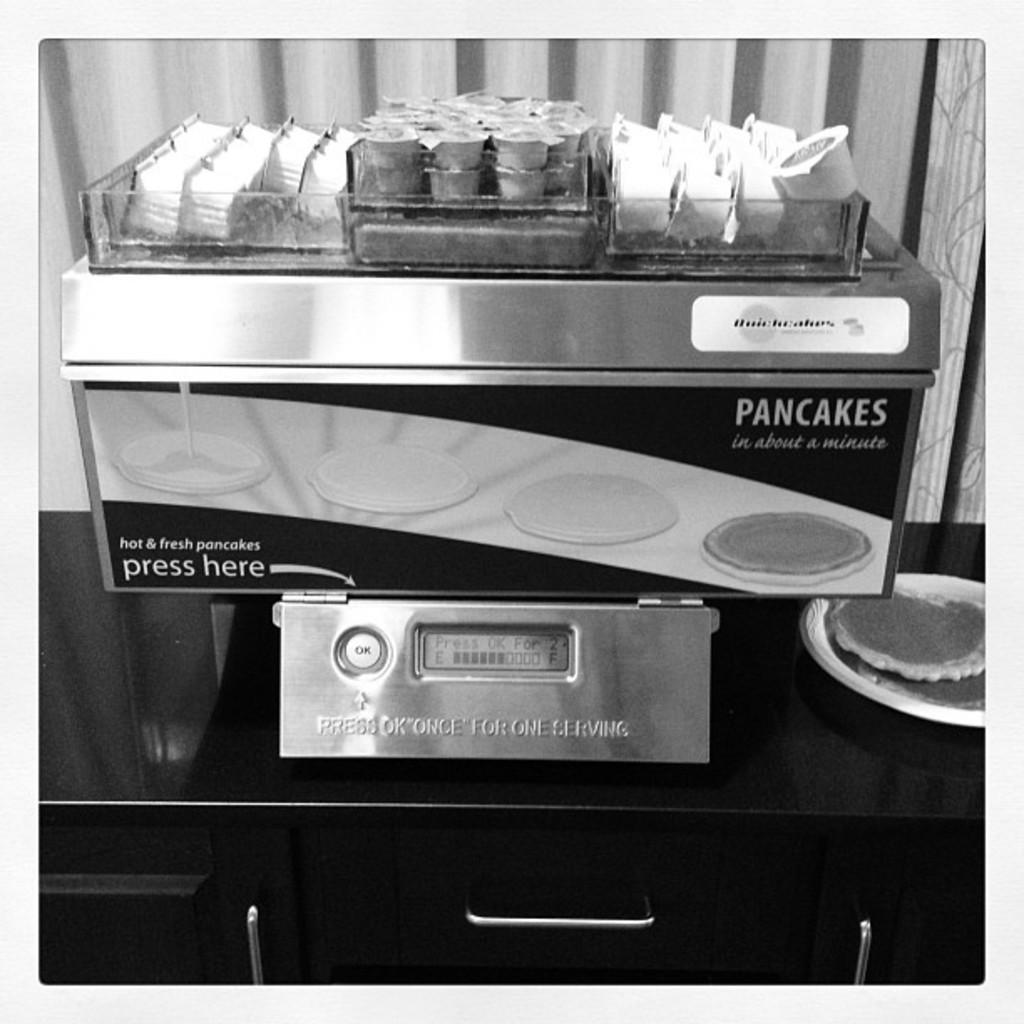<image>
Describe the image concisely. A pancakes in about a minute machine is shown in a black and white photo. 